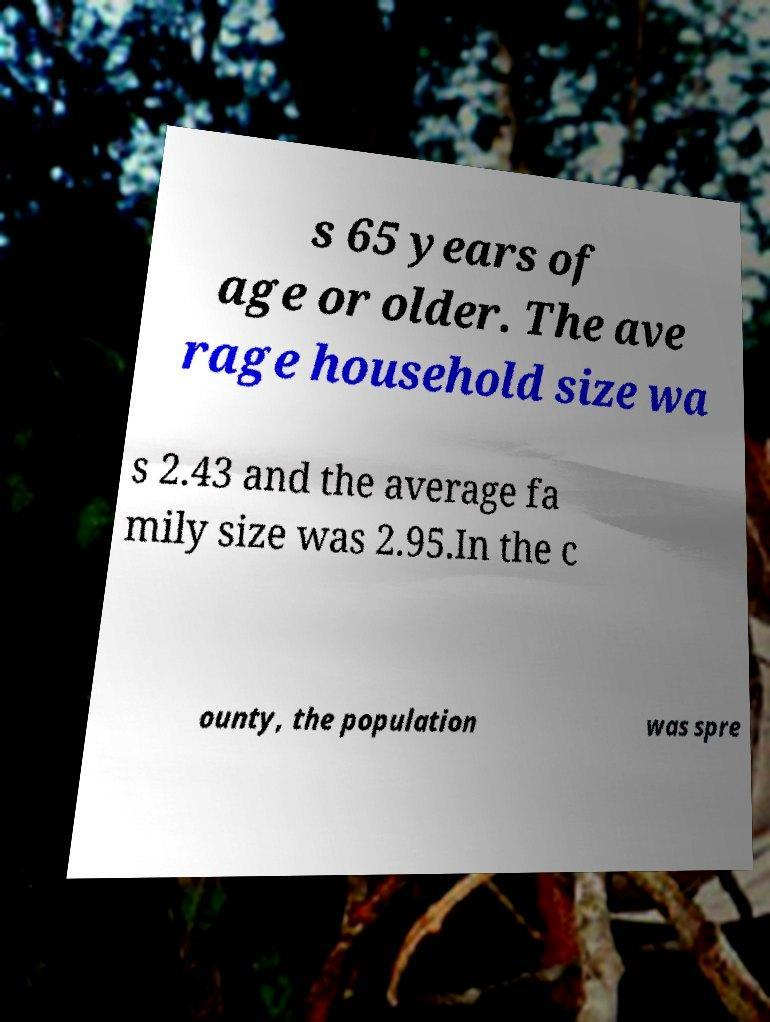Could you extract and type out the text from this image? s 65 years of age or older. The ave rage household size wa s 2.43 and the average fa mily size was 2.95.In the c ounty, the population was spre 